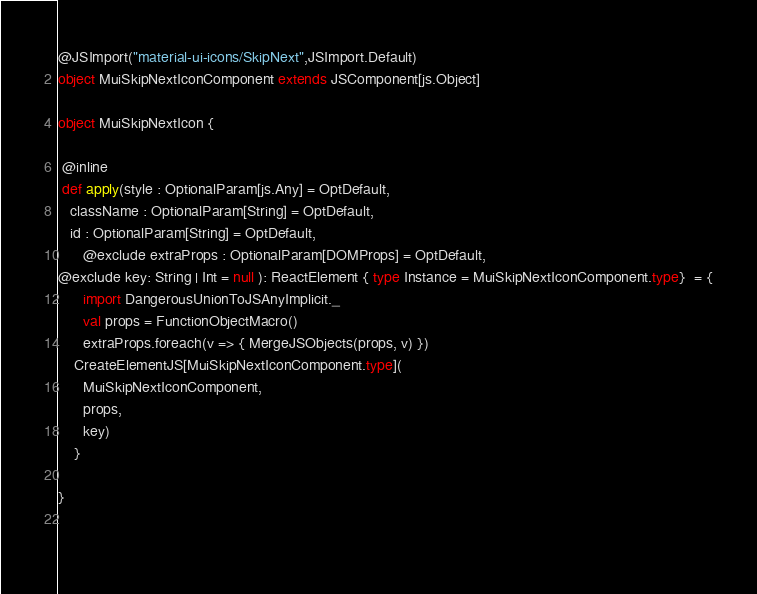<code> <loc_0><loc_0><loc_500><loc_500><_Scala_>@JSImport("material-ui-icons/SkipNext",JSImport.Default)
object MuiSkipNextIconComponent extends JSComponent[js.Object]

object MuiSkipNextIcon {

 @inline
 def apply(style : OptionalParam[js.Any] = OptDefault,
   className : OptionalParam[String] = OptDefault,
   id : OptionalParam[String] = OptDefault,
      @exclude extraProps : OptionalParam[DOMProps] = OptDefault,
@exclude key: String | Int = null ): ReactElement { type Instance = MuiSkipNextIconComponent.type}  = {
      import DangerousUnionToJSAnyImplicit._
      val props = FunctionObjectMacro()
      extraProps.foreach(v => { MergeJSObjects(props, v) })
    CreateElementJS[MuiSkipNextIconComponent.type](
      MuiSkipNextIconComponent,
      props,
      key)
    }

}

        
</code> 